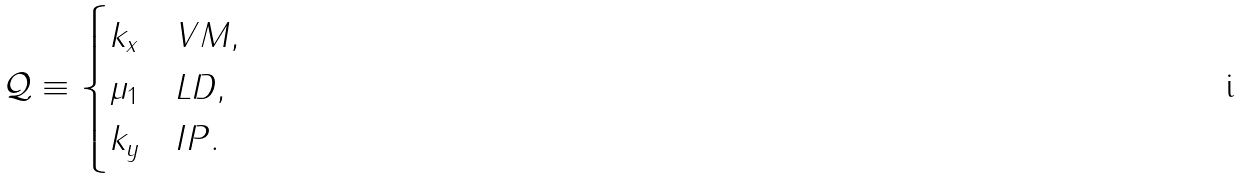<formula> <loc_0><loc_0><loc_500><loc_500>\mathcal { Q } \equiv \begin{cases} k _ { x } & V M , \\ \mu _ { 1 } & L D , \\ k _ { y } & I P . \end{cases}</formula> 